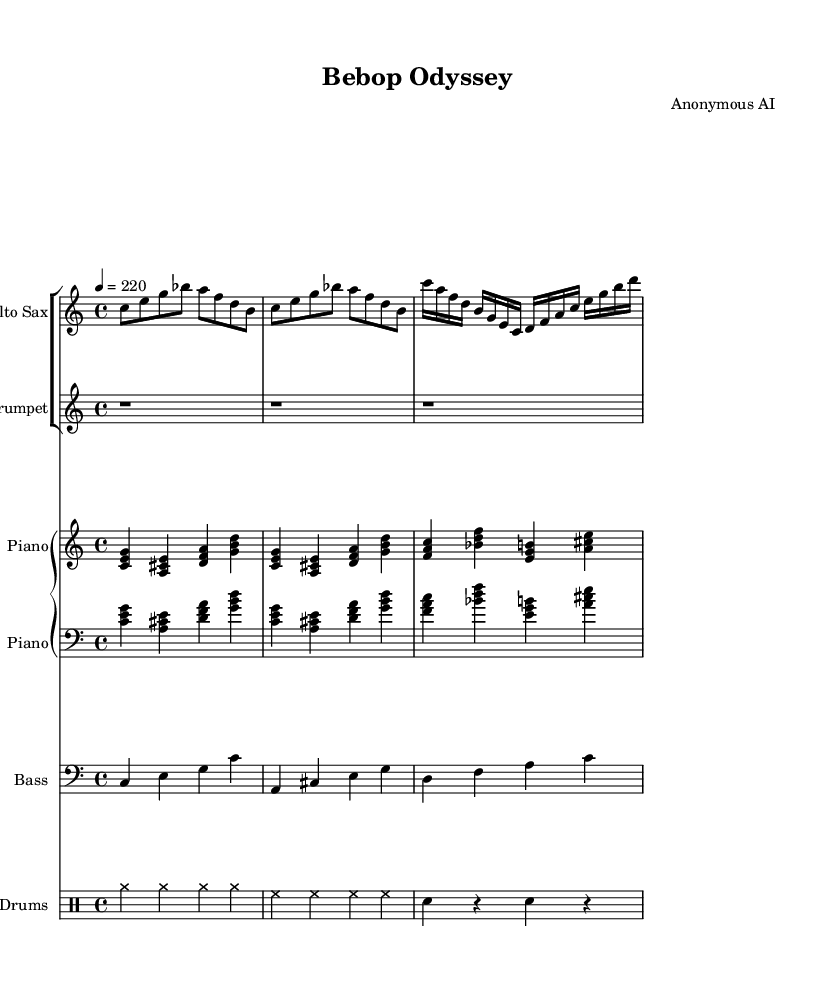What is the key signature of this music? The key signature is C major, which is indicated by the absence of any sharps or flats in the signature. You can find it at the beginning of the staff.
Answer: C major What is the time signature of this music? The time signature is found at the beginning of the score, and it indicates a common 4/4 time signature. This tells us there are four beats in a measure.
Answer: 4/4 What is the tempo marking of this piece? The tempo marking is indicated as a metronome marking of 220 beats per minute, which signifies the speed at which the music should be played. It can be found at the beginning of the score.
Answer: 220 How many instruments are in this score? The score features five distinct instrumental parts: Alto Sax, Trumpet, Piano, Bass, and Drums. Each is represented by a separate staff.
Answer: Five Which instrument plays the highest pitch in this composition? When analyzing the given parts, we look at the range of each instrument. The Alto Sax plays notes up to a higher register compared to the others, including a high C in the melody.
Answer: Alto Sax What type of musical elements are predominant in bebop jazz, represented in this score? Bebop often includes complex chord progressions and fast tempos, as seen in the intricate rhythms and harmonies used throughout this composition. Additionally, the piece showcases improvisational styles and syncopation typical of bebop.
Answer: Complex chords 